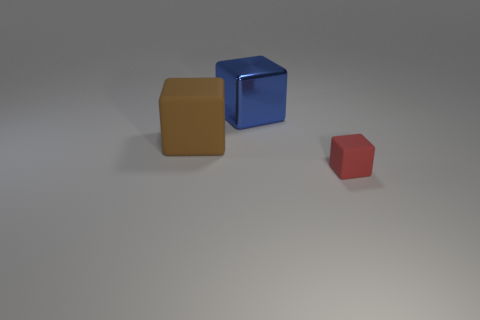Add 2 large blue objects. How many objects exist? 5 Add 1 large blue things. How many large blue things are left? 2 Add 2 big blue shiny blocks. How many big blue shiny blocks exist? 3 Subtract 0 purple cubes. How many objects are left? 3 Subtract all large blue cubes. Subtract all blue cylinders. How many objects are left? 2 